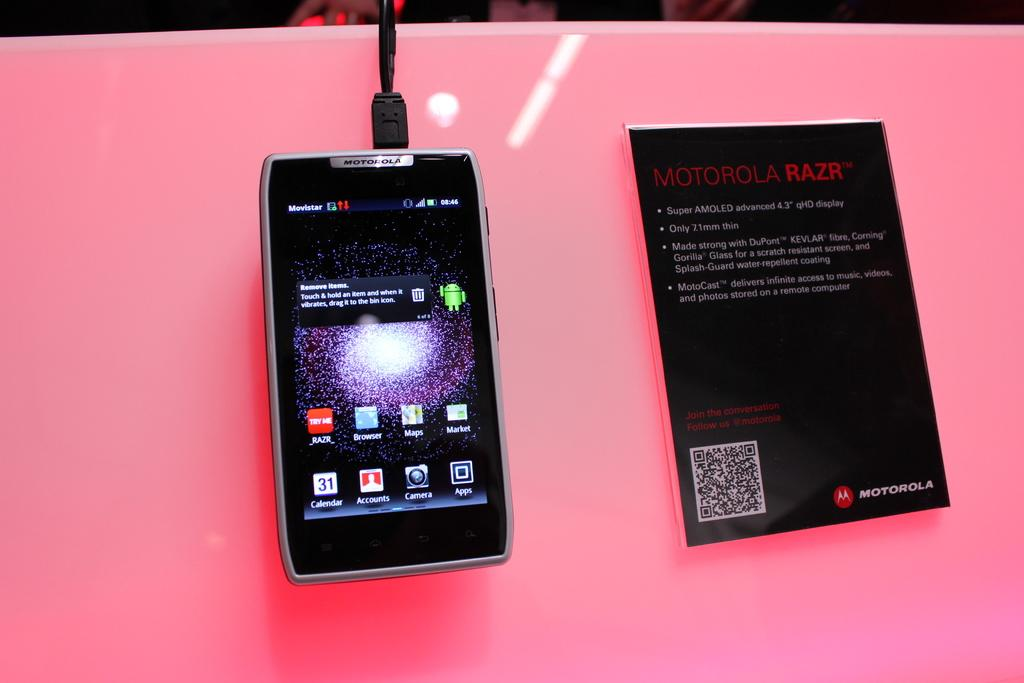<image>
Summarize the visual content of the image. A Motorola Razr phone lays on a pink display with an information pamphlet next to it. 